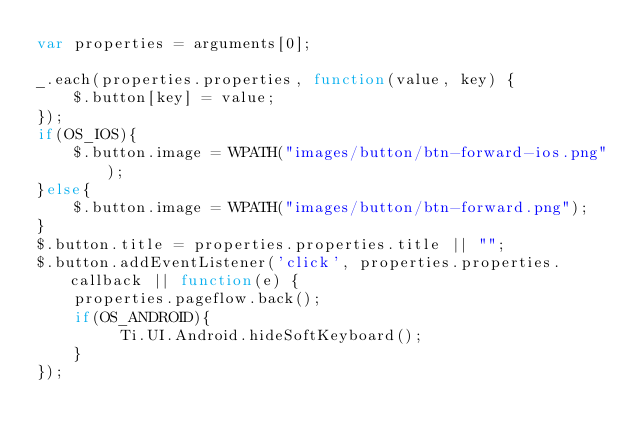Convert code to text. <code><loc_0><loc_0><loc_500><loc_500><_JavaScript_>var properties = arguments[0];

_.each(properties.properties, function(value, key) {
    $.button[key] = value;
});
if(OS_IOS){
	$.button.image = WPATH("images/button/btn-forward-ios.png");
}else{
	$.button.image = WPATH("images/button/btn-forward.png");
}
$.button.title = properties.properties.title || "";
$.button.addEventListener('click', properties.properties.callback || function(e) {
    properties.pageflow.back();
    if(OS_ANDROID){
         Ti.UI.Android.hideSoftKeyboard();
    }    
});
</code> 